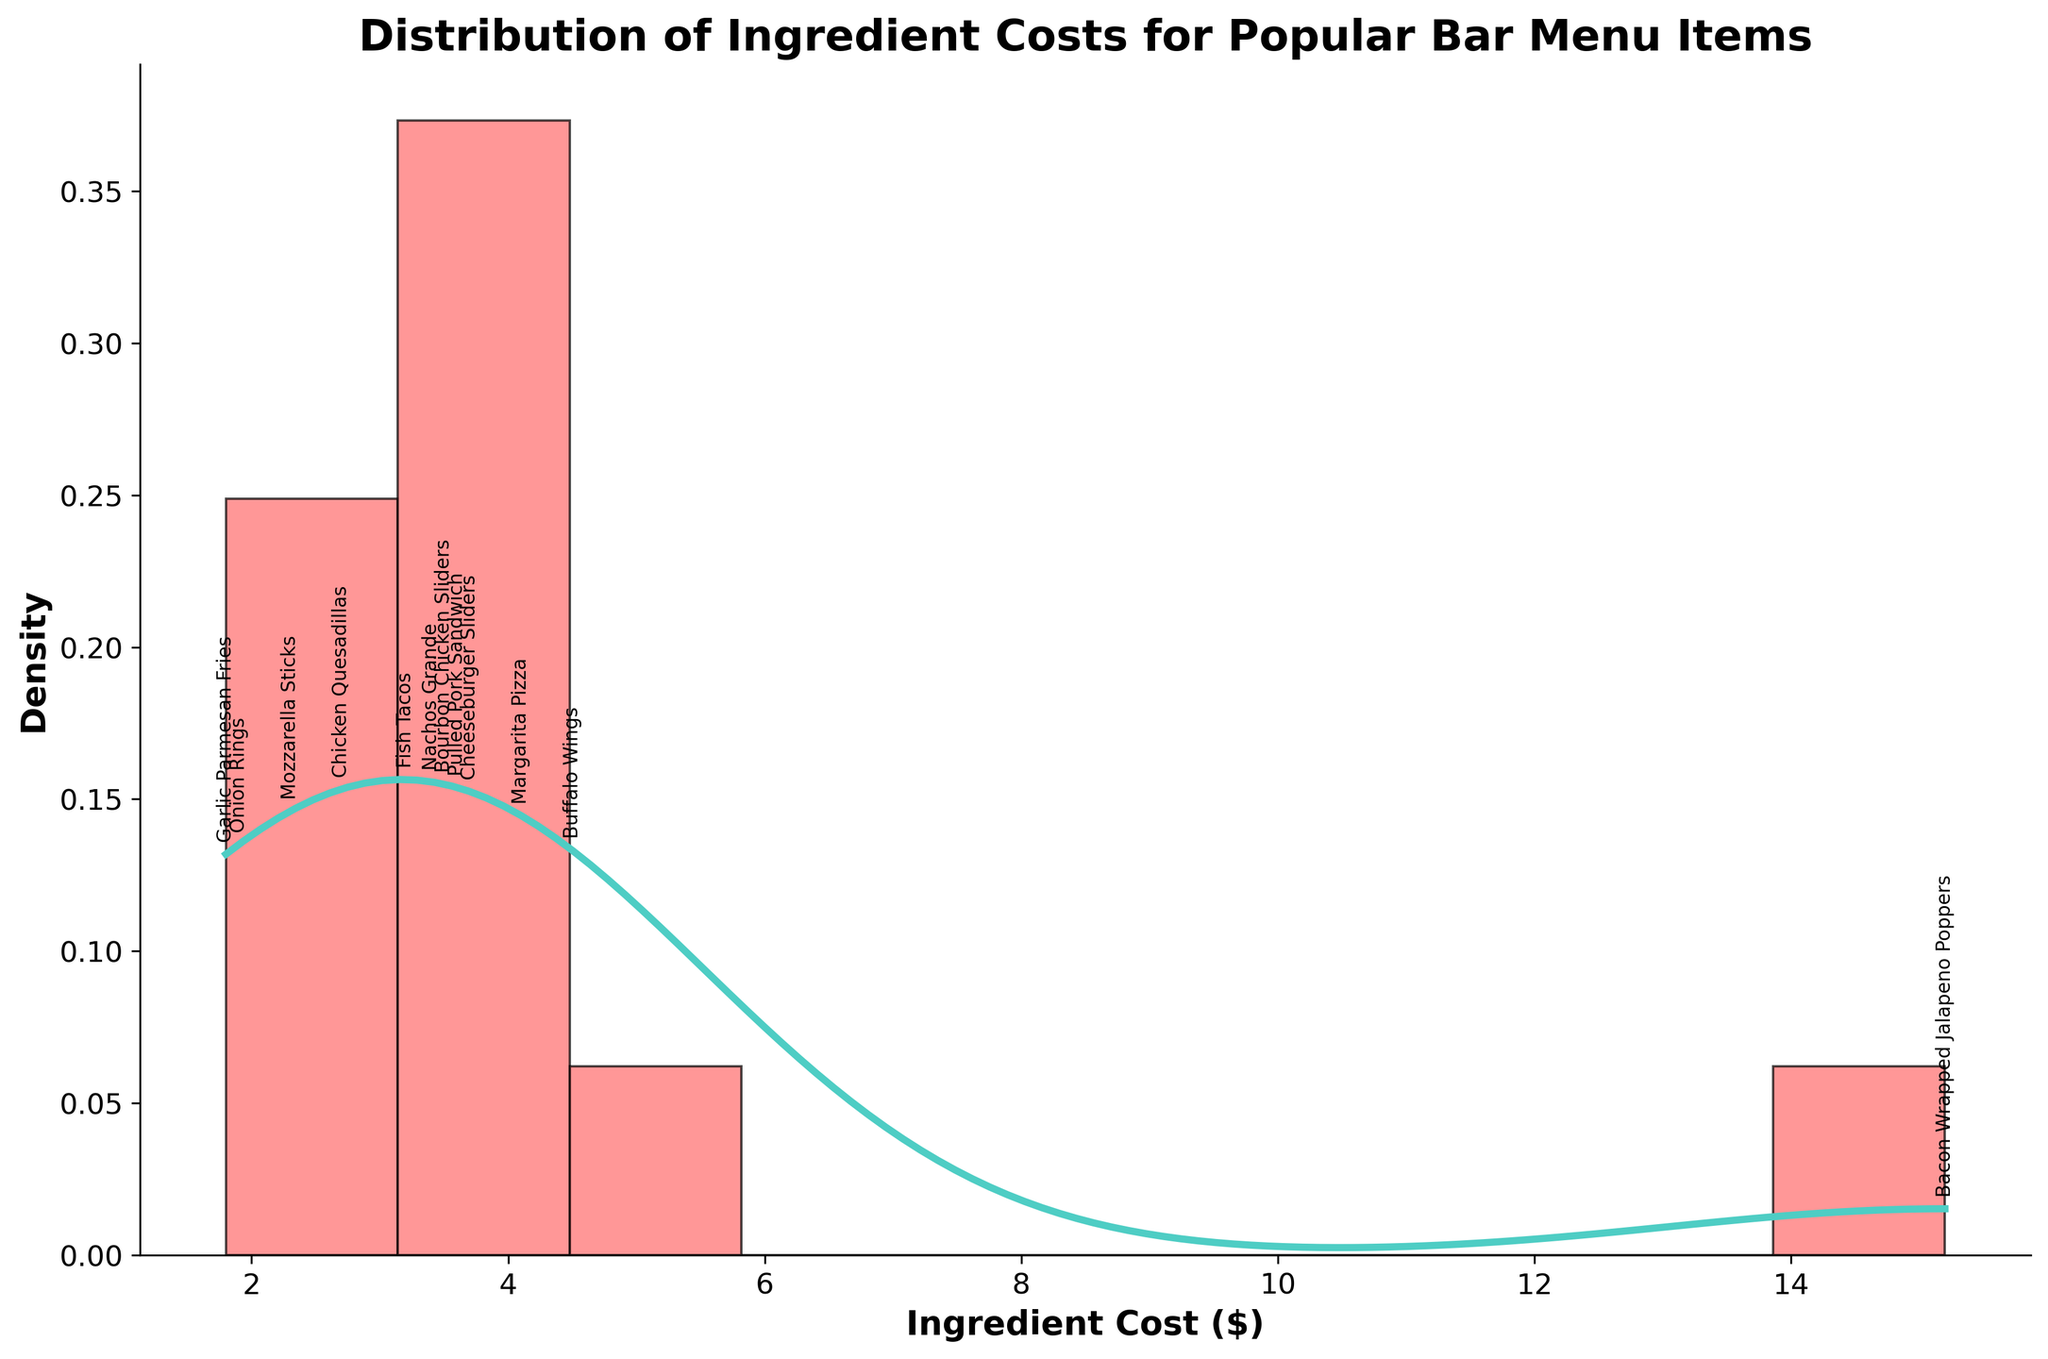What is the title of the plot? The title is written at the top of the plot. It allows viewers to know what the plot is about.
Answer: Distribution of Ingredient Costs for Popular Bar Menu Items How many data points are represented in the plot? By counting the number of names annotated on the x-axis, you can see that there are 12 different items.
Answer: 12 What is the cost of the most expensive menu item? By looking at the x-axis annotations, the Bacon Wrapped Jalapeno Poppers cost is the highest at $15.2.
Answer: $15.2 Which menu item has the lowest ingredient cost? By examining the annotations and the leftmost bar in the histogram, Garlic Parmesan Fries has the lowest cost of $1.8.
Answer: Garlic Parmesan Fries What is the median ingredient cost of the menu items? To find the median, list all costs ($1.8, $1.9, $2.3, $2.7, $3.2, $3.4, $3.5, $3.6, $3.7, $4.1, $4.5, $15.2) and find the middle value. Since there are 12 items, the median will be the average of the 6th and 7th values (3.4 and 3.5).
Answer: $3.45 Which menu items have ingredient costs between $3.0 and $4.0? By checking the annotations between $3.0 and $4.0 on the x-axis, you can identify the items within this range—Chicken Quesadillas, Fish Tacos, Nachos Grande, Pulled Pork Sandwich, and Cheeseburger Sliders.
Answer: Chicken Quesadillas, Fish Tacos, Nachos Grande, Pulled Pork Sandwich, Cheeseburger Sliders What is the range of ingredient costs in the plot? The range is the difference between the highest and lowest costs. The highest is $15.2 (Bacon Wrapped Jalapeno Poppers) and the lowest is $1.8 (Garlic Parmesan Fries). So, the range is $15.2 - $1.8.
Answer: $13.4 Which menu item has an ingredient cost closest to the average ingredient cost? First, calculate the average cost: $\frac{sum\ of\ all\ costs}{number\ of\ items}=\frac{sum\ of\ all\ costs\ (manually\ do\ the\ sum)}{12} = \frac{51.9}{12}= 4.325$. Buffalo Wings at $4.5 is the closest to $4.325$.
Answer: Buffalo Wings Is the distribution of ingredient costs skewed, and if so, in which direction? By looking at the histogram and the KDE plot, if the bulk of data is to the left and the tail to the right, it indicates right or positive skewness.
Answer: Right (positive skew) How does the density of ingredient costs between $1.8 and $4.5 compare to those above $4.5? By looking at the density curve, the density between $1.8 and $4.5 is higher compared to the density above $4.5, where only one item, Bacon Wrapped Jalapeno Poppers, exists.
Answer: Higher between $1.8 and $4.5 